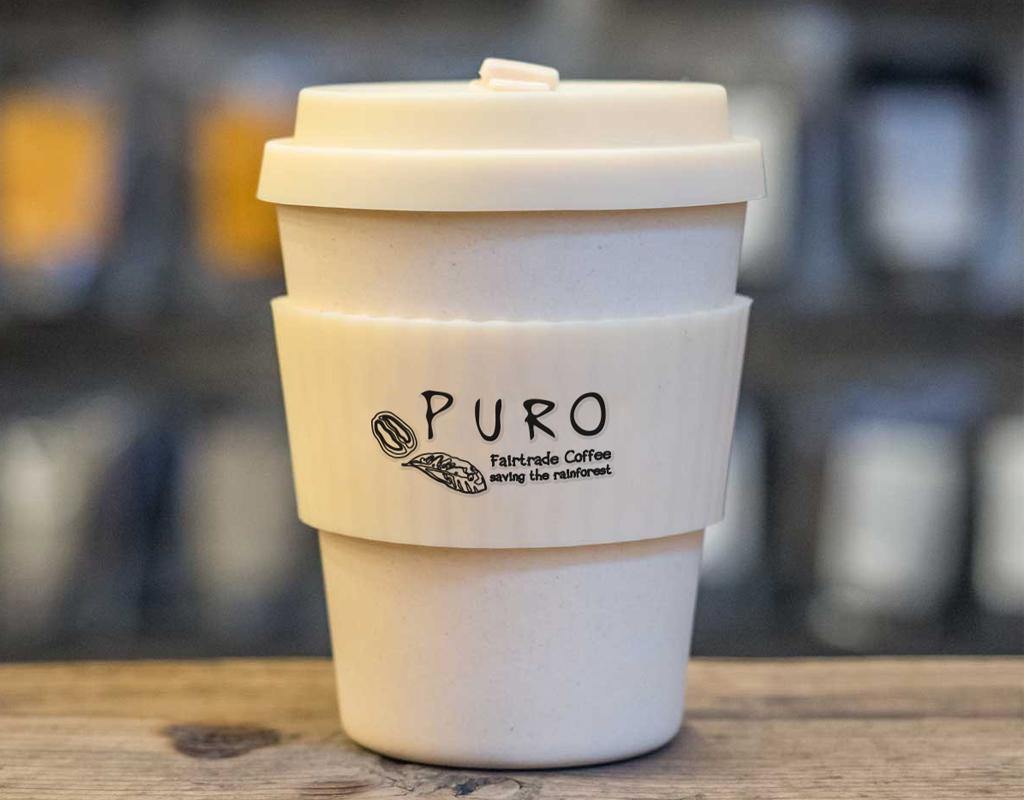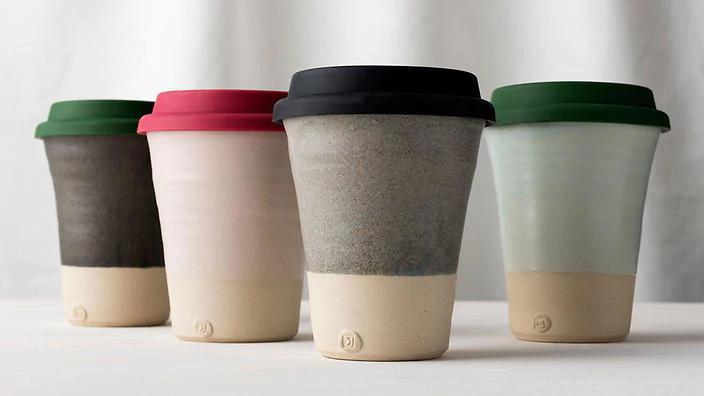The first image is the image on the left, the second image is the image on the right. Evaluate the accuracy of this statement regarding the images: "There are exactly two cups.". Is it true? Answer yes or no. No. The first image is the image on the left, the second image is the image on the right. Evaluate the accuracy of this statement regarding the images: "There are only two disposable coffee cups.". Is it true? Answer yes or no. No. 